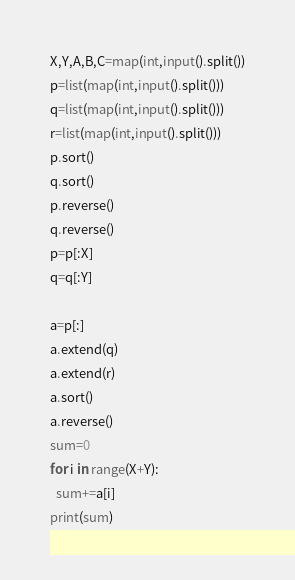Convert code to text. <code><loc_0><loc_0><loc_500><loc_500><_Python_>X,Y,A,B,C=map(int,input().split())
p=list(map(int,input().split()))
q=list(map(int,input().split()))
r=list(map(int,input().split()))
p.sort()
q.sort()
p.reverse()
q.reverse()
p=p[:X]
q=q[:Y]
 
a=p[:]
a.extend(q)
a.extend(r)
a.sort()
a.reverse()
sum=0
for i in range(X+Y):
  sum+=a[i]
print(sum)</code> 